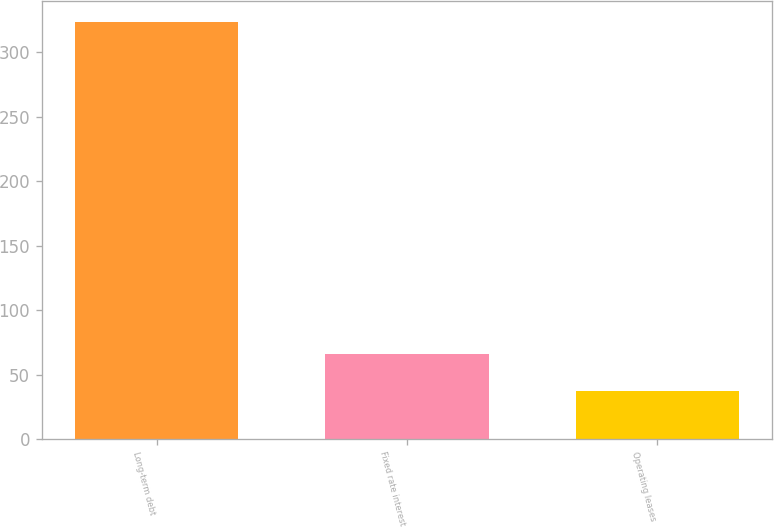Convert chart to OTSL. <chart><loc_0><loc_0><loc_500><loc_500><bar_chart><fcel>Long-term debt<fcel>Fixed rate interest<fcel>Operating leases<nl><fcel>323.6<fcel>66.02<fcel>37.4<nl></chart> 